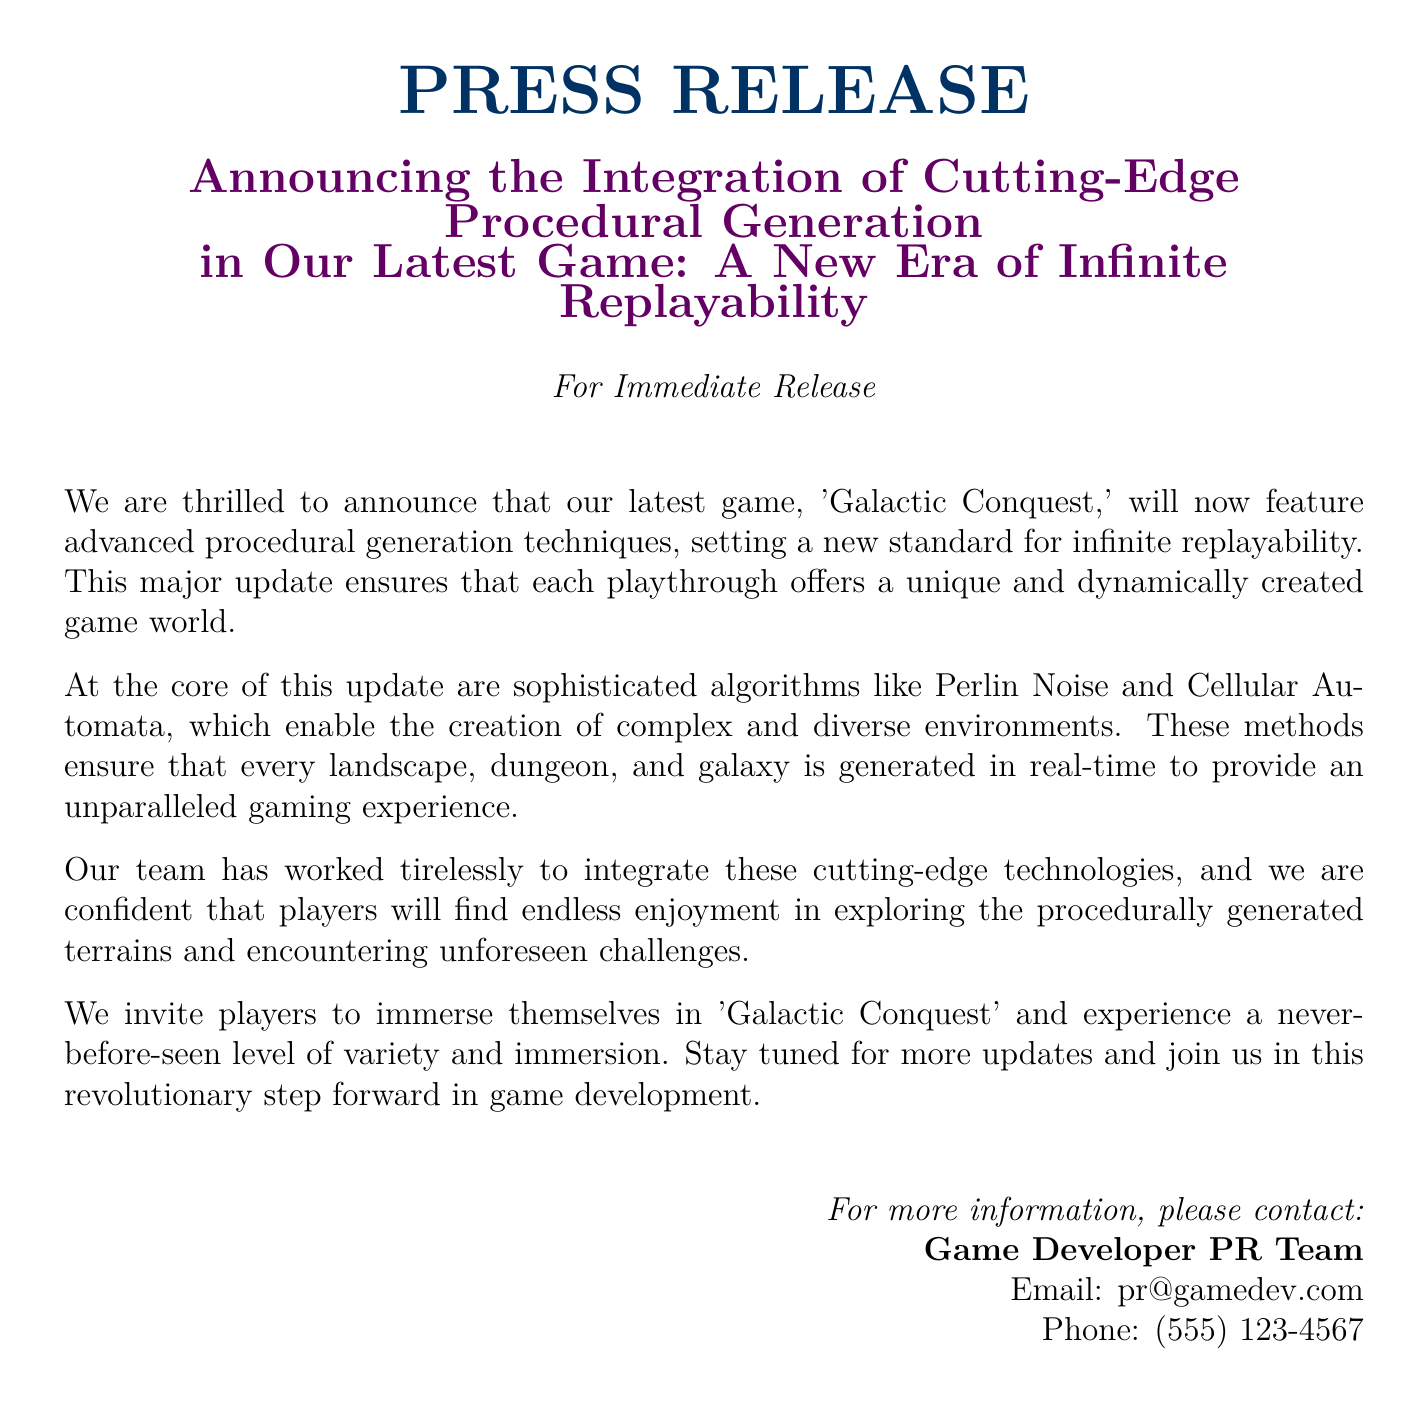What is the name of the game featured in the press release? The name of the game is mentioned in the title of the press release, which is 'Galactic Conquest.'
Answer: 'Galactic Conquest' What advanced techniques are integrated into the game? The document specifically mentions advanced procedural generation techniques being integrated into the game.
Answer: Procedural generation techniques What are the algorithms mentioned in the update? The press release lists specific algorithms being used for the procedural generation, including Perlin Noise and Cellular Automata.
Answer: Perlin Noise and Cellular Automata What is the expected outcome for players from this update? The release states that the update aims to provide players with a unique and dynamically created game world, enhancing their gaming experience.
Answer: Unique gaming experience Who should be contacted for more information? The press release lists a contact point for inquiries, specifying the 'Game Developer PR Team' as the contact entity.
Answer: Game Developer PR Team How does the document characterize the update? It refers to the update as a "revolutionary step forward in game development," indicating its significance.
Answer: Revolutionary step forward What type of document is this? The document is explicitly labeled at the top as a "PRESS RELEASE," which identifies its purpose.
Answer: PRESS RELEASE 